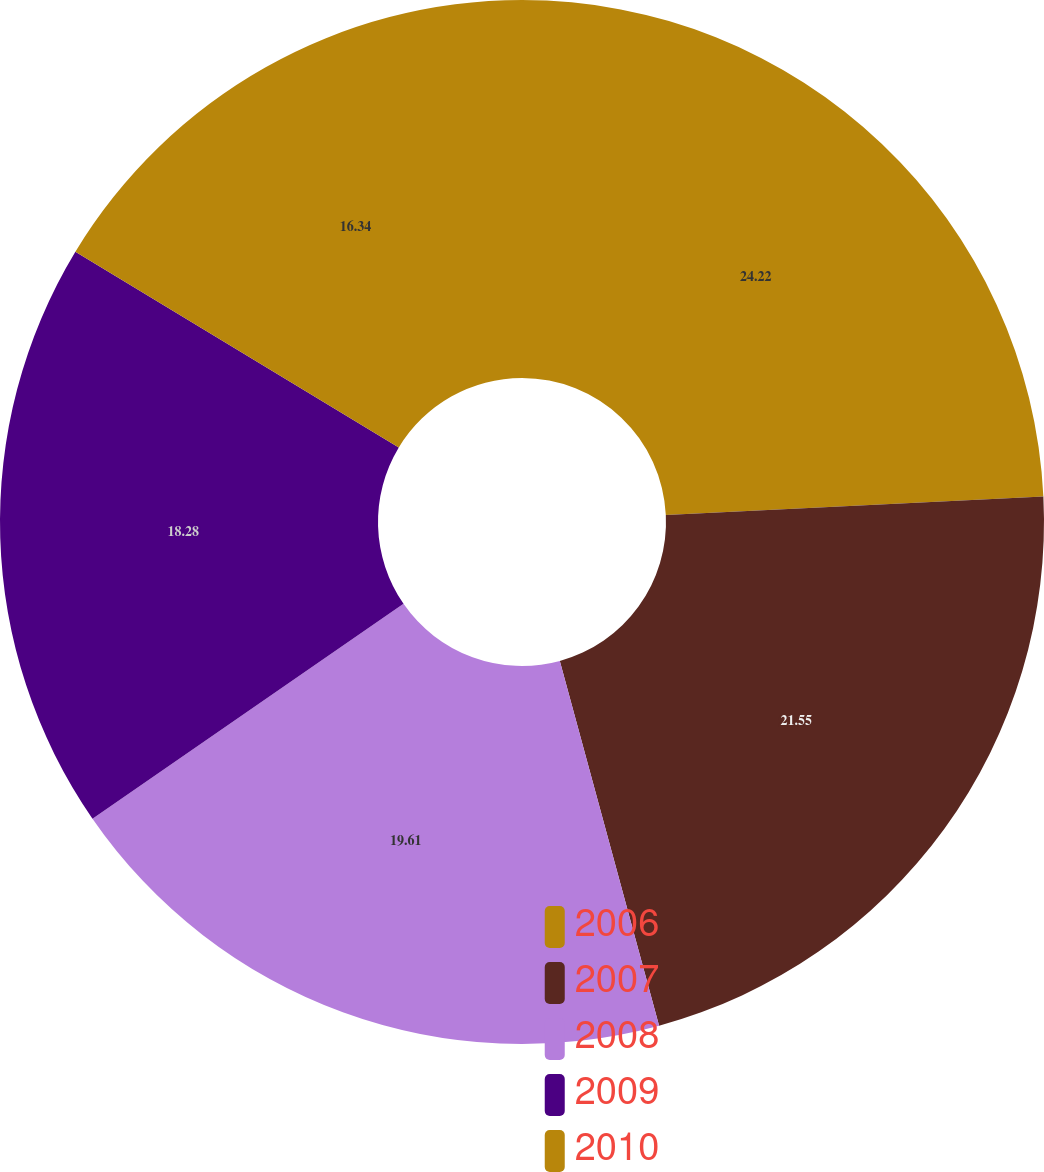<chart> <loc_0><loc_0><loc_500><loc_500><pie_chart><fcel>2006<fcel>2007<fcel>2008<fcel>2009<fcel>2010<nl><fcel>24.22%<fcel>21.55%<fcel>19.61%<fcel>18.28%<fcel>16.34%<nl></chart> 